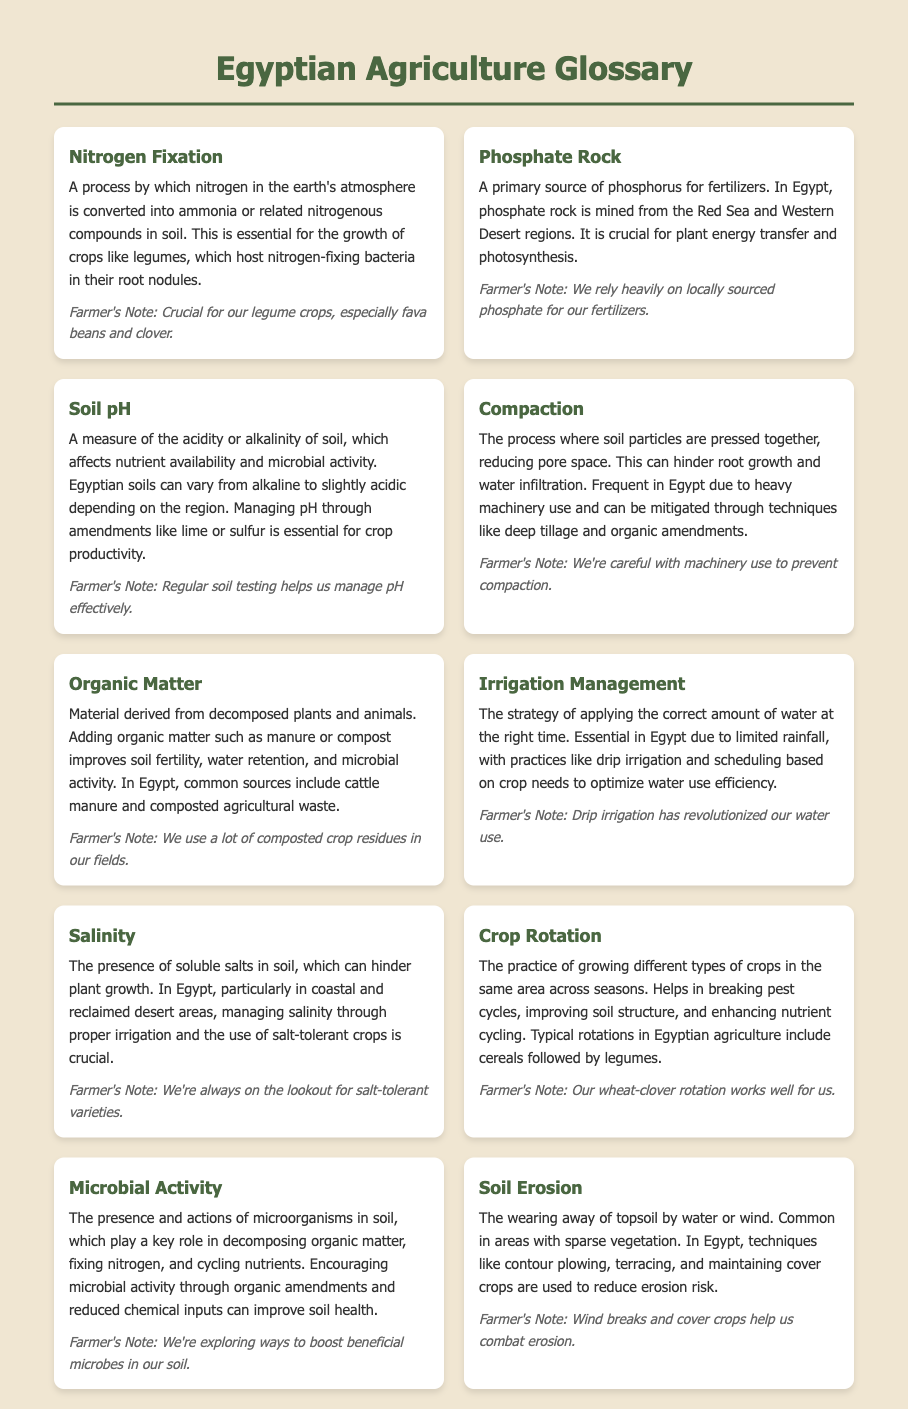What is nitrogen fixation? Nitrogen fixation is defined in the document as the process by which nitrogen in the earth's atmosphere is converted into ammonia or related nitrogenous compounds in soil.
Answer: A process by which nitrogen in the earth's atmosphere is converted into ammonia What is the primary source of phosphorus for fertilizers in Egypt? The document states that phosphate rock is a primary source of phosphorus for fertilizers in Egypt.
Answer: Phosphate rock What does soil pH measure? According to the glossary, soil pH measures the acidity or alkalinity of soil.
Answer: Acidity or alkalinity What is one method to mitigate compaction? The document lists deep tillage as one method to mitigate compaction in soil.
Answer: Deep tillage What improves soil fertility and water retention? The glossary mentions that adding organic matter improves soil fertility and water retention.
Answer: Organic matter How does irrigation management impact crop growth in Egypt? The document states that it involves applying the correct amount of water at the right time, which is essential due to limited rainfall.
Answer: Applying the correct amount of water What is the consequence of soil erosion? The glossary explains that soil erosion results in the wearing away of topsoil by water or wind.
Answer: Wearing away of topsoil What is commonly used to reduce erosion risk in Egypt? The document highlights cover crops as a technique used to reduce erosion risk.
Answer: Cover crops How can microbial activity be encouraged in soil? The glossary states that microbial activity can be encouraged through organic amendments and reduced chemical inputs.
Answer: Organic amendments and reduced chemical inputs 